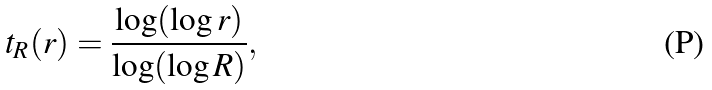Convert formula to latex. <formula><loc_0><loc_0><loc_500><loc_500>t _ { R } ( r ) = \frac { \log ( \log r ) } { \log ( \log R ) } ,</formula> 